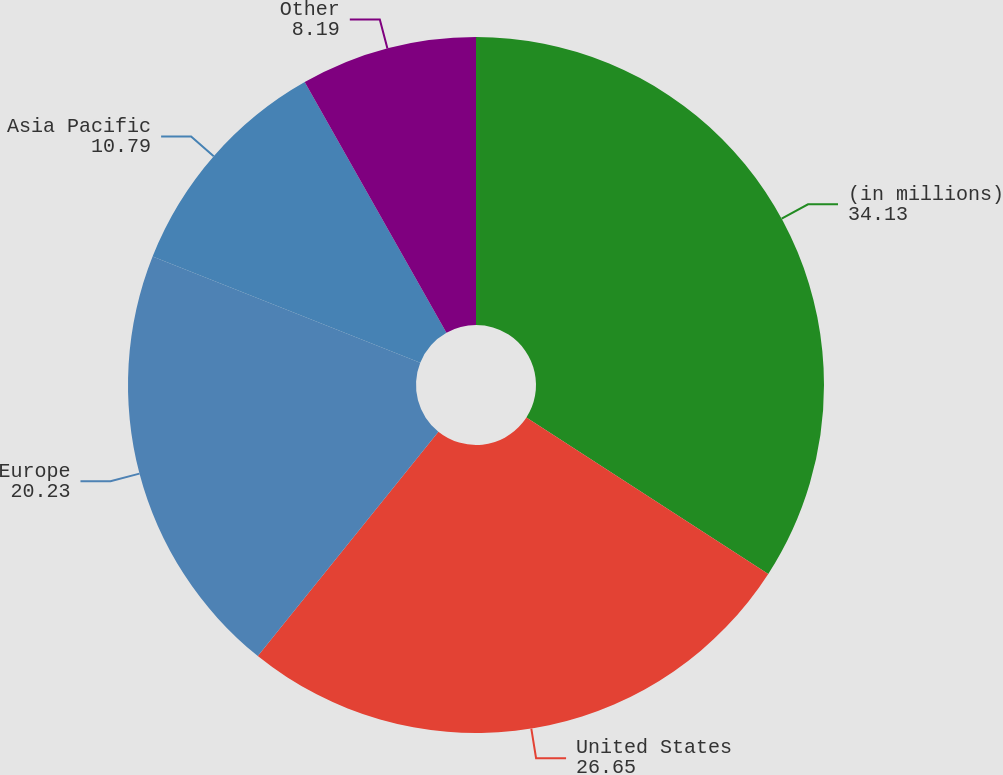Convert chart to OTSL. <chart><loc_0><loc_0><loc_500><loc_500><pie_chart><fcel>(in millions)<fcel>United States<fcel>Europe<fcel>Asia Pacific<fcel>Other<nl><fcel>34.13%<fcel>26.65%<fcel>20.23%<fcel>10.79%<fcel>8.19%<nl></chart> 